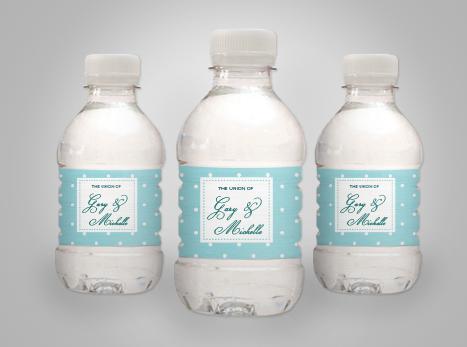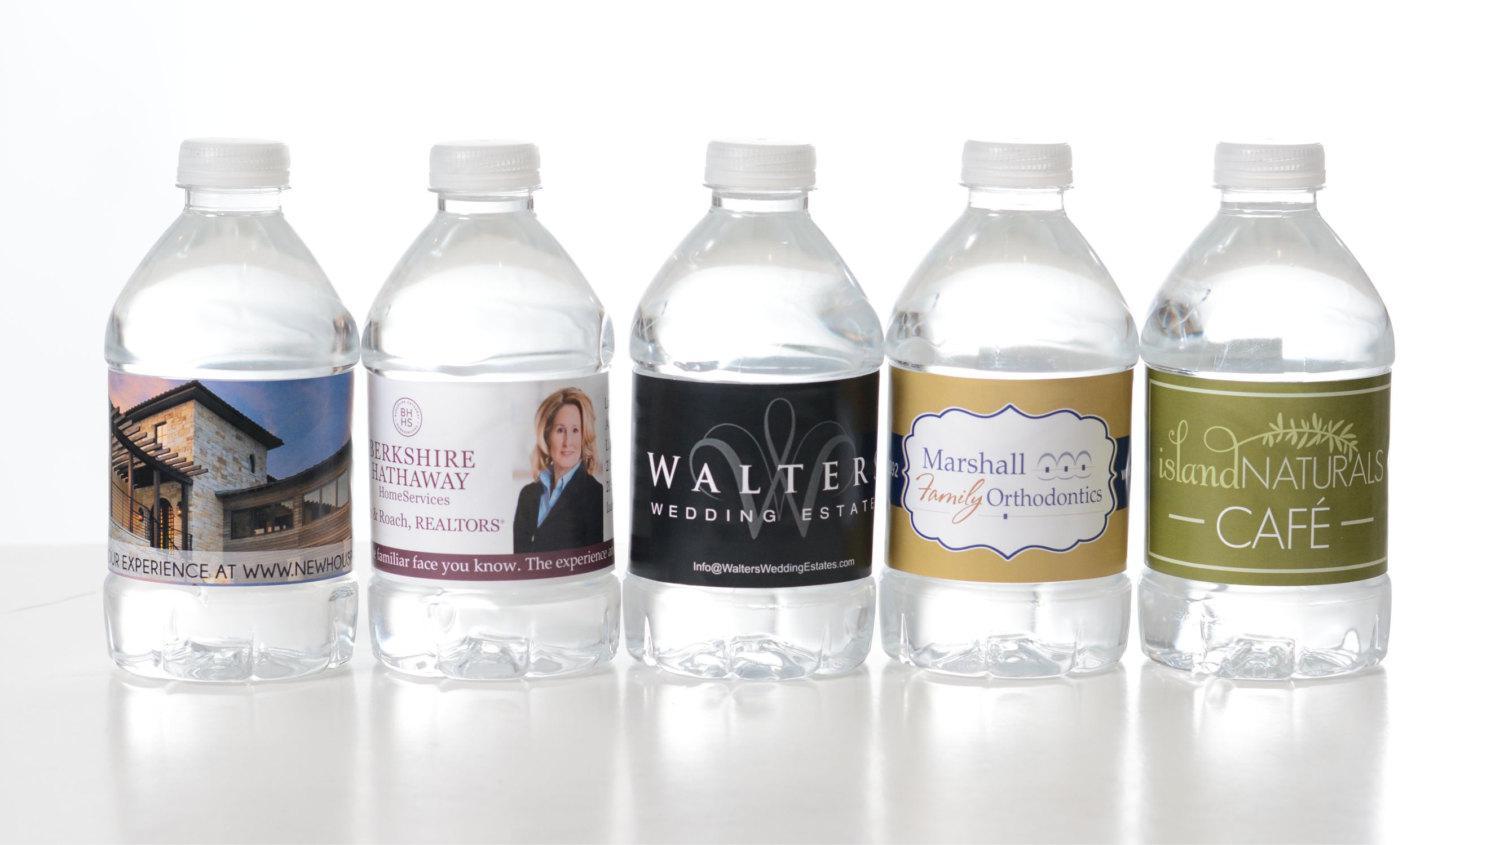The first image is the image on the left, the second image is the image on the right. Considering the images on both sides, is "There are two more bottles in one of the images than in the other." valid? Answer yes or no. Yes. The first image is the image on the left, the second image is the image on the right. For the images shown, is this caption "There are less than eight disposable plastic water bottles" true? Answer yes or no. No. 